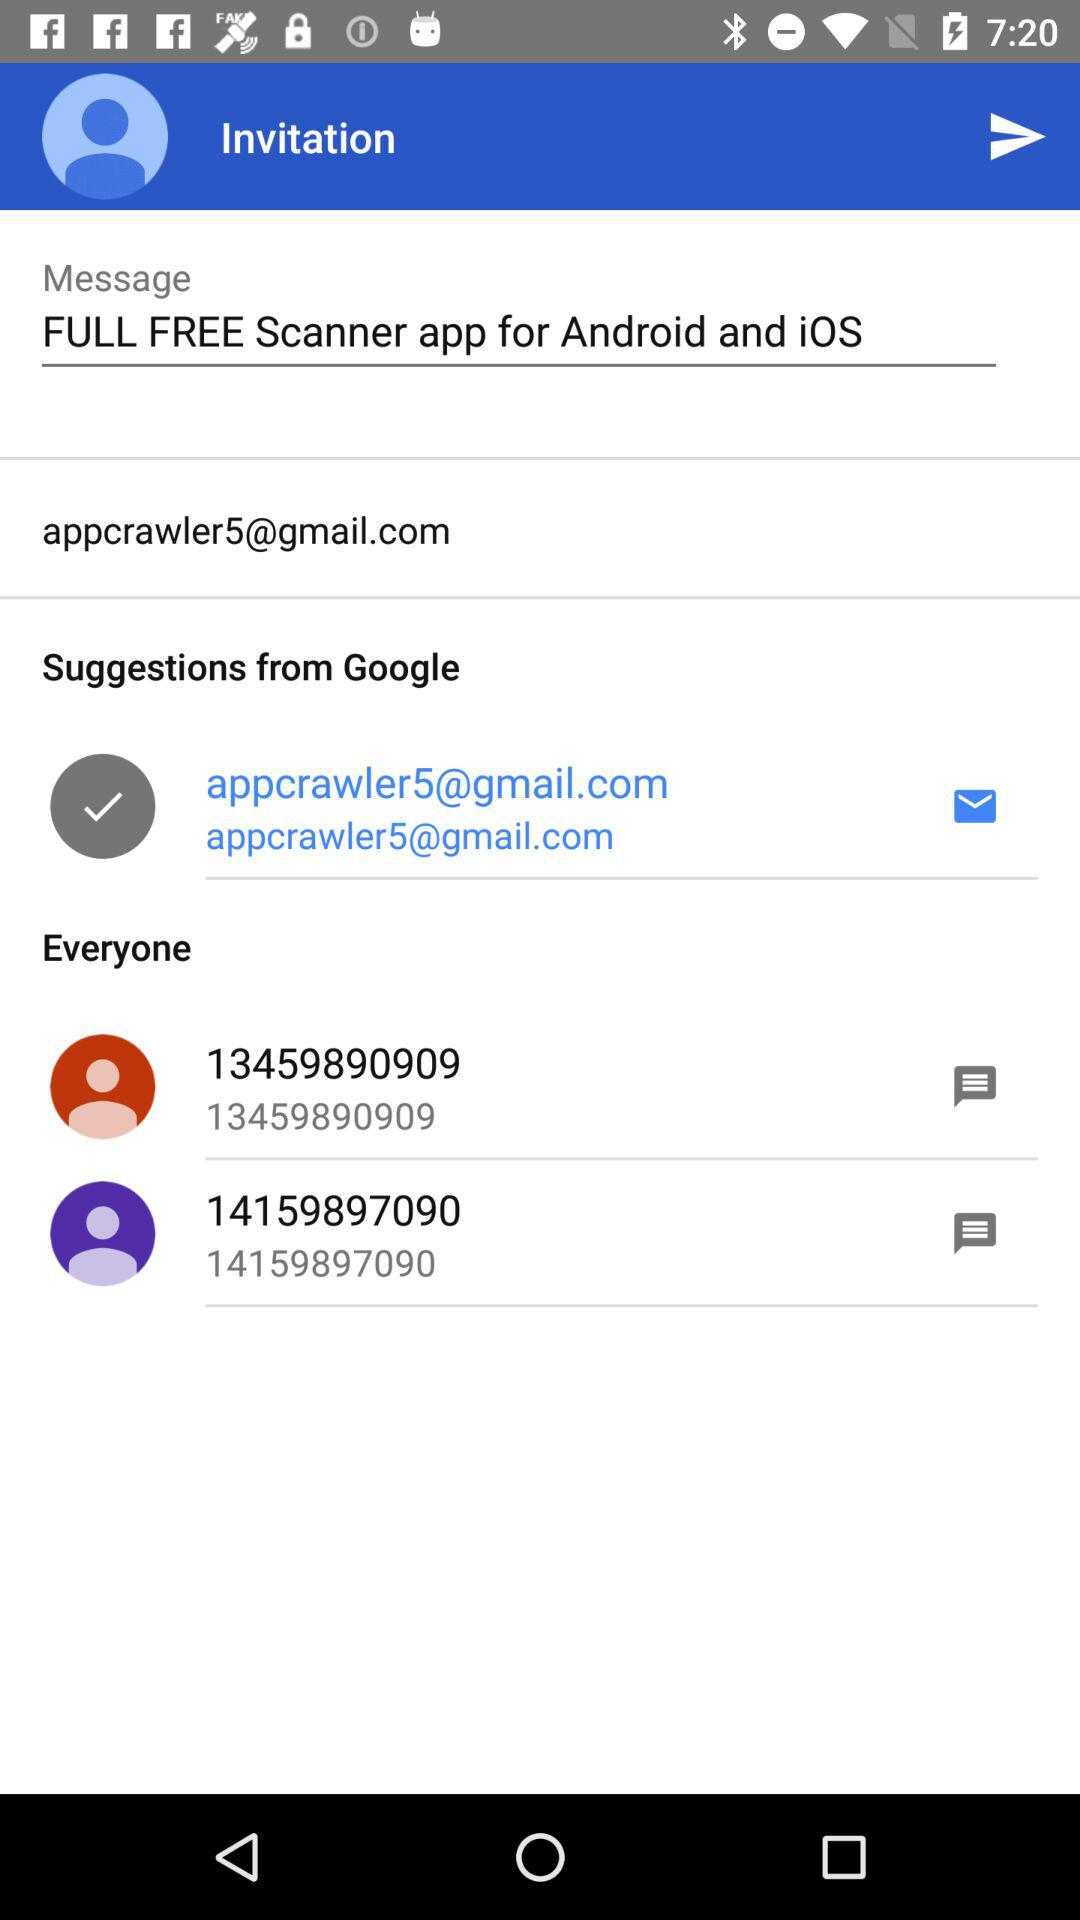What is the email address? The email address is appcrawler5@gmail.com. 